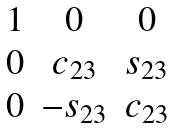Convert formula to latex. <formula><loc_0><loc_0><loc_500><loc_500>\begin{matrix} 1 & 0 & 0 \\ 0 & c _ { 2 3 } & s _ { 2 3 } \\ 0 & - s _ { 2 3 } & c _ { 2 3 } \\ \end{matrix}</formula> 